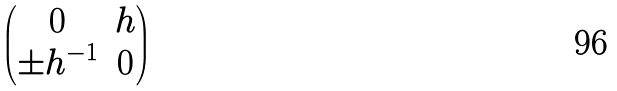Convert formula to latex. <formula><loc_0><loc_0><loc_500><loc_500>\begin{pmatrix} 0 & h \\ \pm h ^ { - 1 } & 0 \end{pmatrix}</formula> 